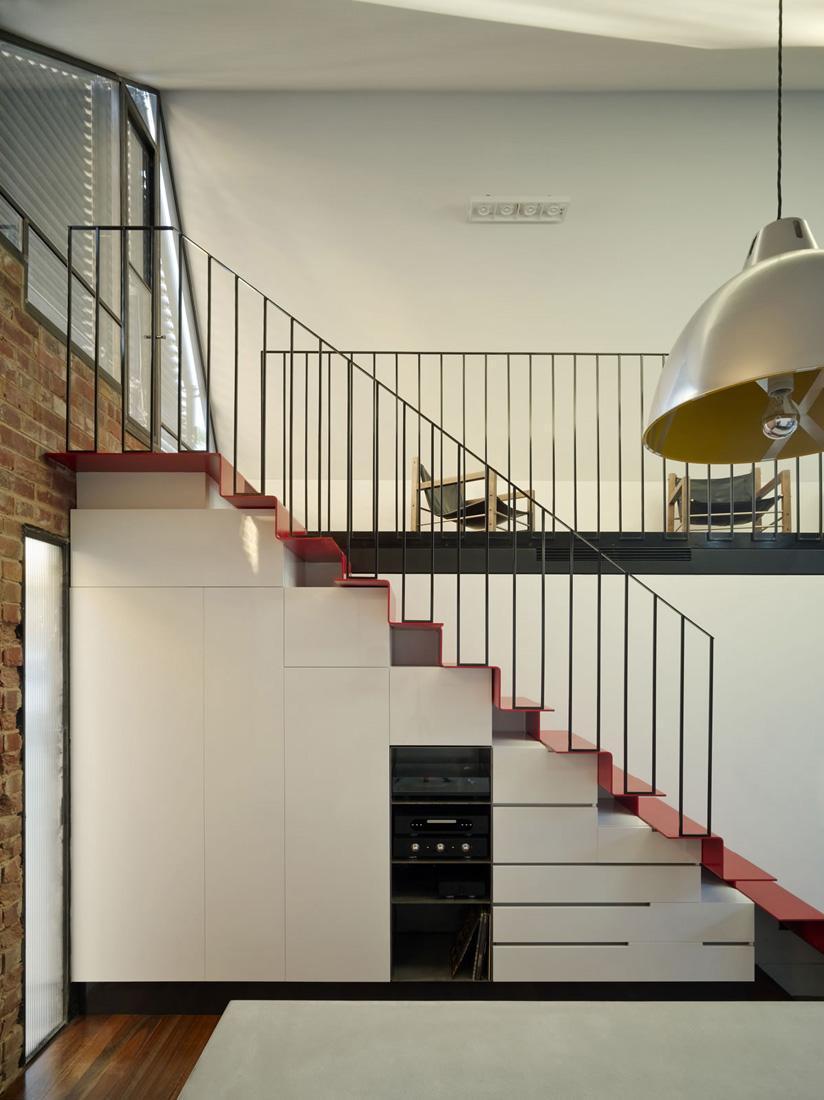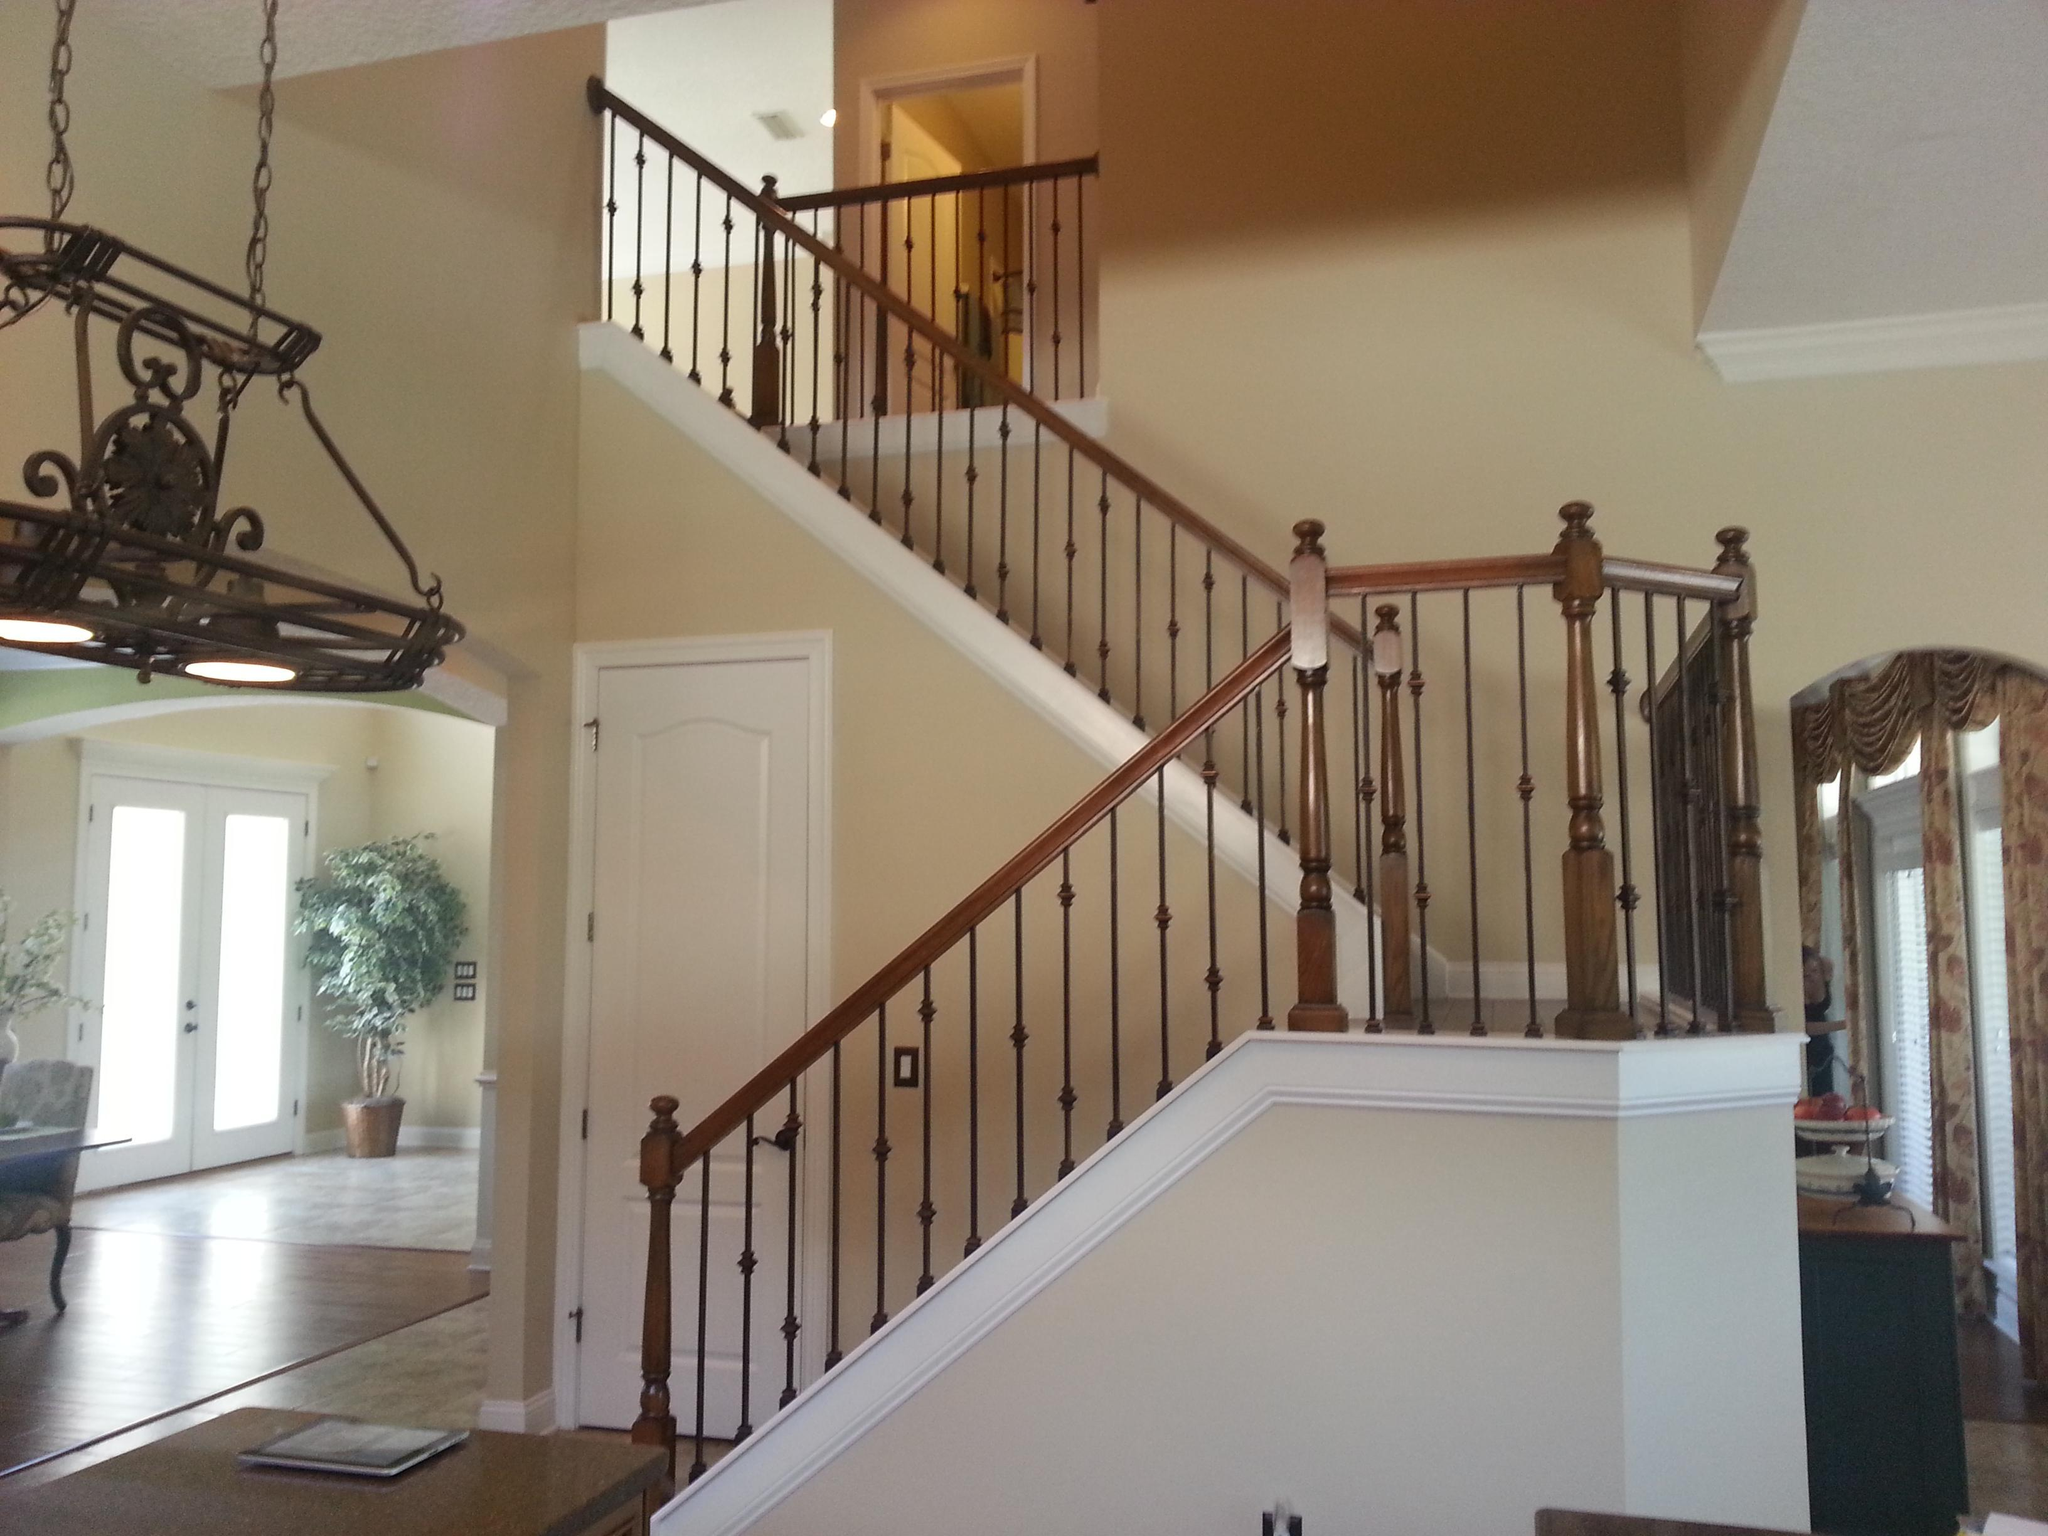The first image is the image on the left, the second image is the image on the right. Evaluate the accuracy of this statement regarding the images: "An image shows a staircase that ascends rightward next to an arch doorway, and the staircase has wooden steps with white base boards.". Is it true? Answer yes or no. No. 